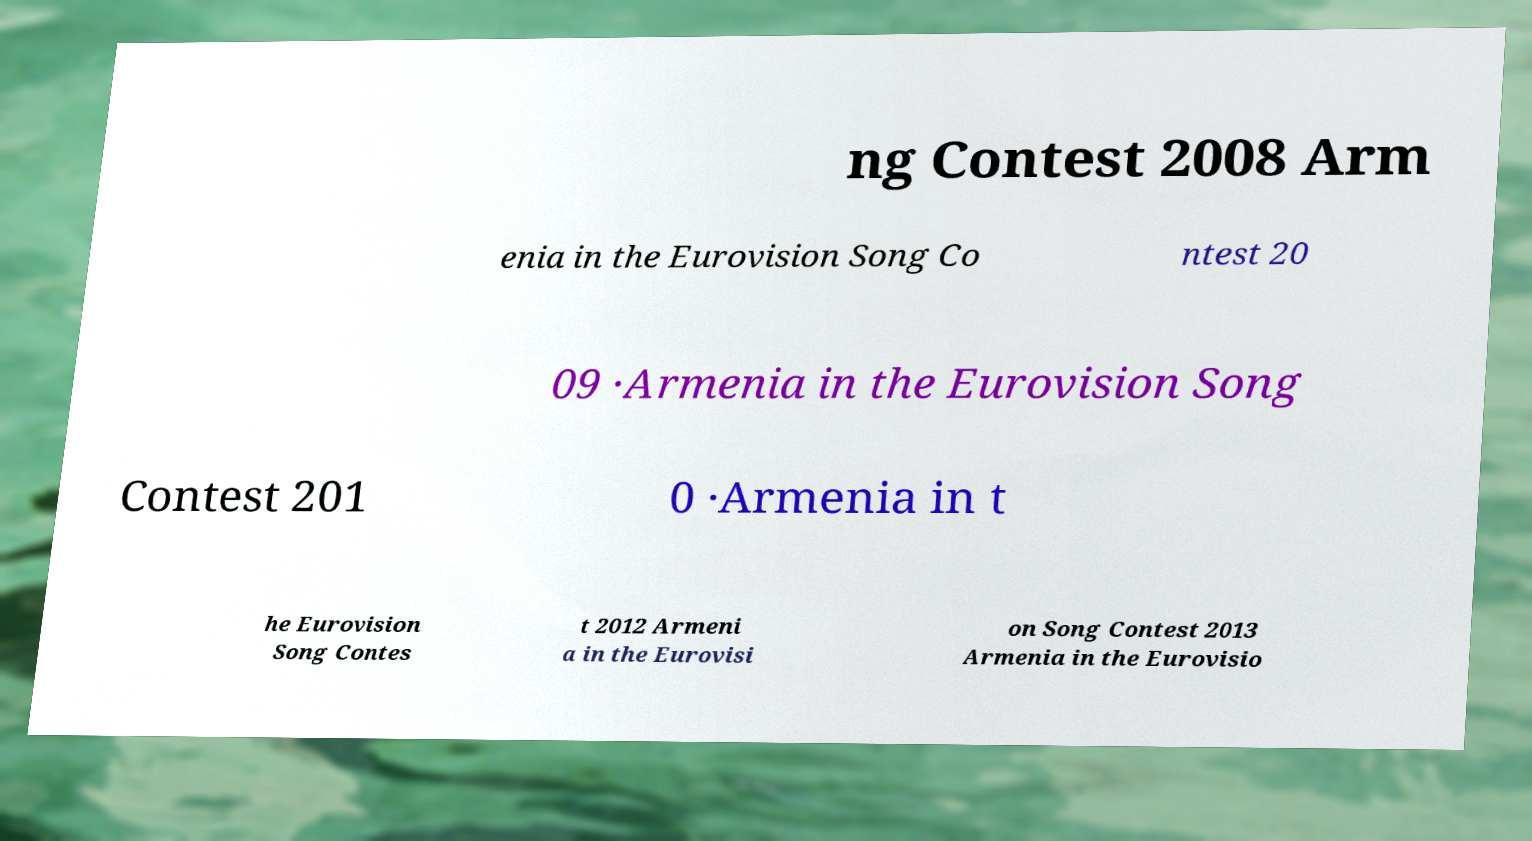Could you assist in decoding the text presented in this image and type it out clearly? ng Contest 2008 Arm enia in the Eurovision Song Co ntest 20 09 ·Armenia in the Eurovision Song Contest 201 0 ·Armenia in t he Eurovision Song Contes t 2012 Armeni a in the Eurovisi on Song Contest 2013 Armenia in the Eurovisio 